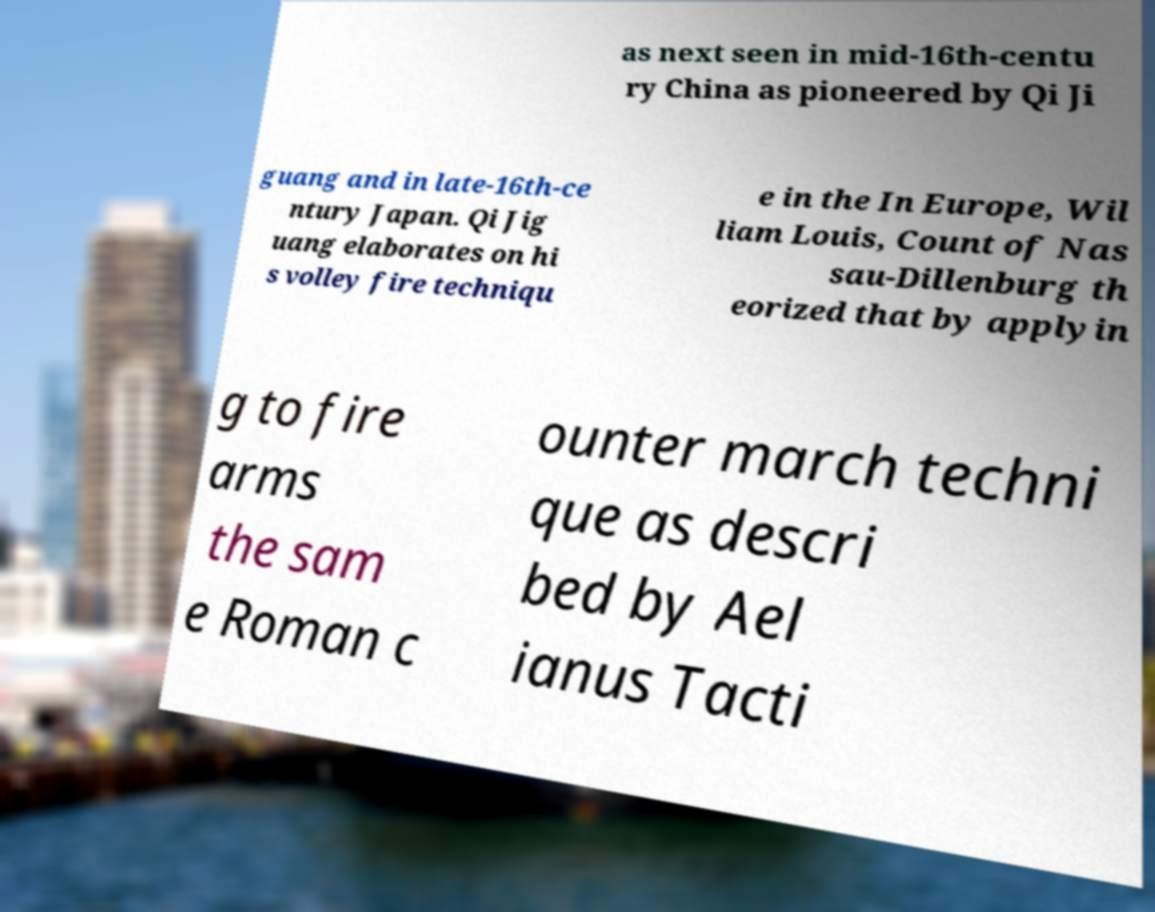Please read and relay the text visible in this image. What does it say? as next seen in mid-16th-centu ry China as pioneered by Qi Ji guang and in late-16th-ce ntury Japan. Qi Jig uang elaborates on hi s volley fire techniqu e in the In Europe, Wil liam Louis, Count of Nas sau-Dillenburg th eorized that by applyin g to fire arms the sam e Roman c ounter march techni que as descri bed by Ael ianus Tacti 